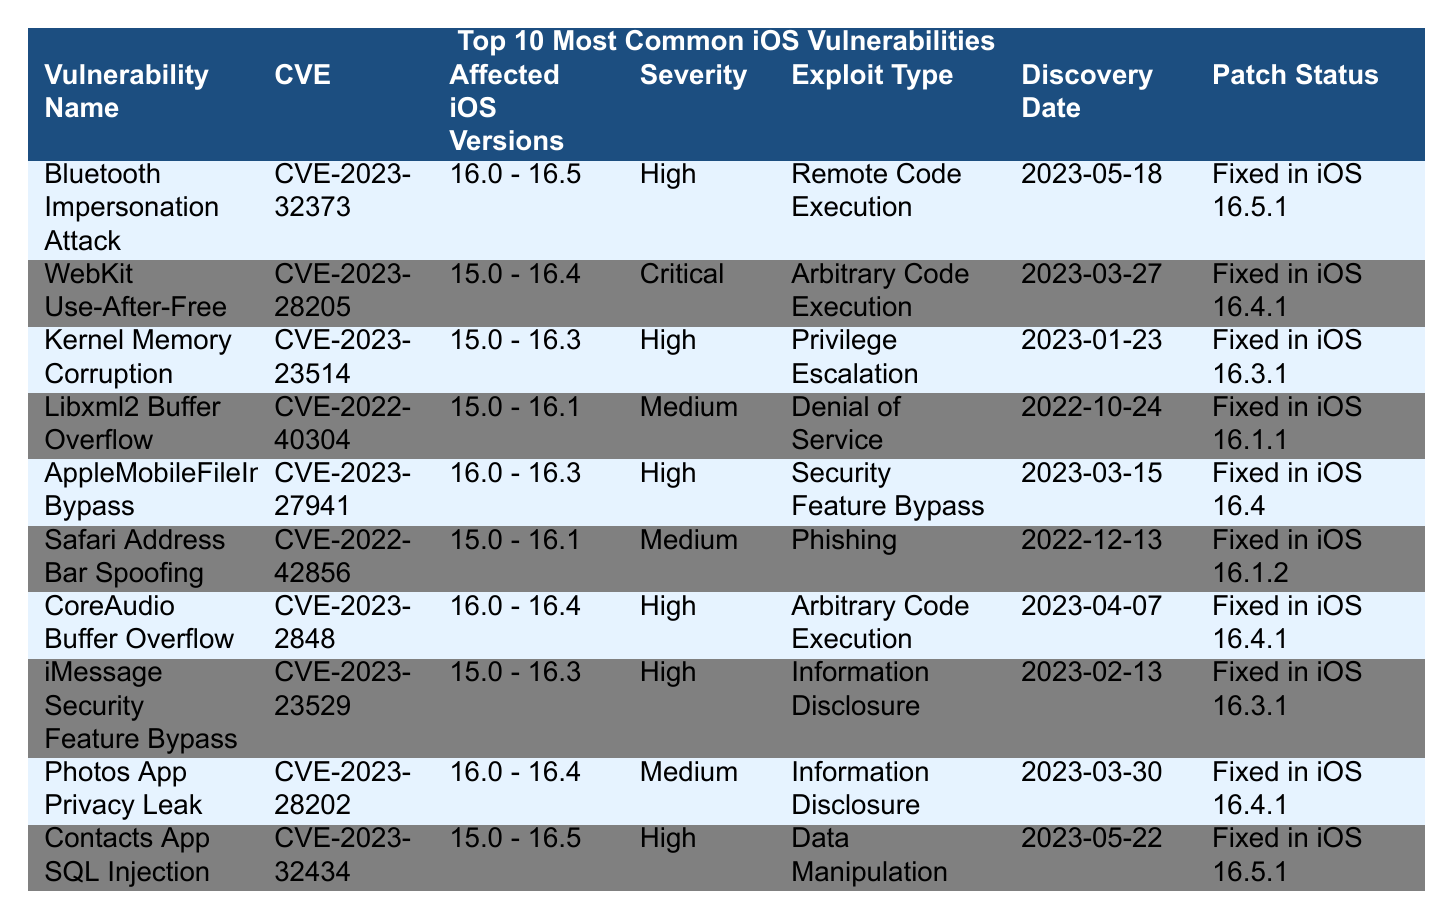What is the CVE for the "Bluetooth Impersonation Attack"? The table lists the CVE as "CVE-2023-32373" under the corresponding vulnerability name.
Answer: CVE-2023-32373 How many vulnerabilities discovered in the last year have a severity rating of "High"? By examining the Severity column, four vulnerabilities are listed with a severity of "High": "Bluetooth Impersonation Attack," "Kernel Memory Corruption," "AppleMobileFileIntegrity Bypass," and "Contacts App SQL Injection."
Answer: 4 Which vulnerability has the highest severity rating? The table indicates that "WebKit Use-After-Free" has a severity rated as "Critical," which is the highest category shown in the data.
Answer: WebKit Use-After-Free What is the latest discovery date among the listed vulnerabilities? A review of the Discovery Date column shows the latest date is "2023-05-22," associated with the "Contacts App SQL Injection" vulnerability.
Answer: 2023-05-22 Is there any vulnerability that was discovered in March 2023? Yes, both "WebKit Use-After-Free" and "iMessage Security Feature Bypass" were discovered in March 2023 on the 27th and 15th, respectively.
Answer: Yes How many vulnerabilities have been patched in iOS versions 16.4.1 or later? The following vulnerabilities have been fixed in iOS versions 16.4.1 or later: "WebKit Use-After-Free," "CoreAudio Buffer Overflow," "Photos App Privacy Leak," and "Bluetooth Impersonation Attack." That's four vulnerabilities in total.
Answer: 4 Which vulnerability affects the highest number of iOS versions? The "Contacts App SQL Injection" affects the range from iOS 15.0 to 16.5, encompassing the widest range of versions compared to the others listed.
Answer: Contacts App SQL Injection Are there any vulnerabilities listed that were patched before March 2023? Yes, "Libxml2 Buffer Overflow" was discovered in October 2022 and patched in iOS 16.1.1, before March 2023.
Answer: Yes What is the earliest discovery date of the vulnerabilities listed? The earliest discovery date mentioned in the table is "2022-10-24," which corresponds to the "Libxml2 Buffer Overflow" vulnerability.
Answer: 2022-10-24 Calculate the total number of vulnerabilities with a severity rating of "Medium." There are three vulnerabilities rated as "Medium": "Libxml2 Buffer Overflow," "Safari Address Bar Spoofing," and "Photos App Privacy Leak." Their count totals three.
Answer: 3 Which type of attack does the "CoreAudio Buffer Overflow" vulnerability exploit? According to the Exploit Type column, the "CoreAudio Buffer Overflow" is classified as an "Arbitrary Code Execution" attack.
Answer: Arbitrary Code Execution 